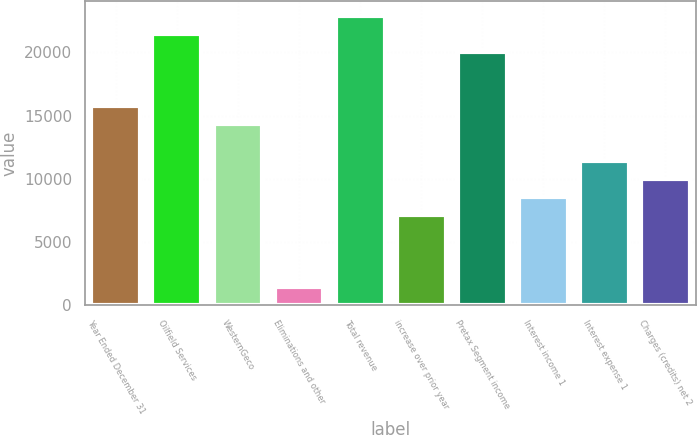<chart> <loc_0><loc_0><loc_500><loc_500><bar_chart><fcel>Year Ended December 31<fcel>Oilfield Services<fcel>WesternGeco<fcel>Eliminations and other<fcel>Total revenue<fcel>increase over prior year<fcel>Pretax Segment income<fcel>Interest income 1<fcel>Interest expense 1<fcel>Charges (credits) net 2<nl><fcel>15739.9<fcel>21463.3<fcel>14309<fcel>1431.28<fcel>22894.2<fcel>7154.72<fcel>20032.5<fcel>8585.58<fcel>11447.3<fcel>10016.4<nl></chart> 